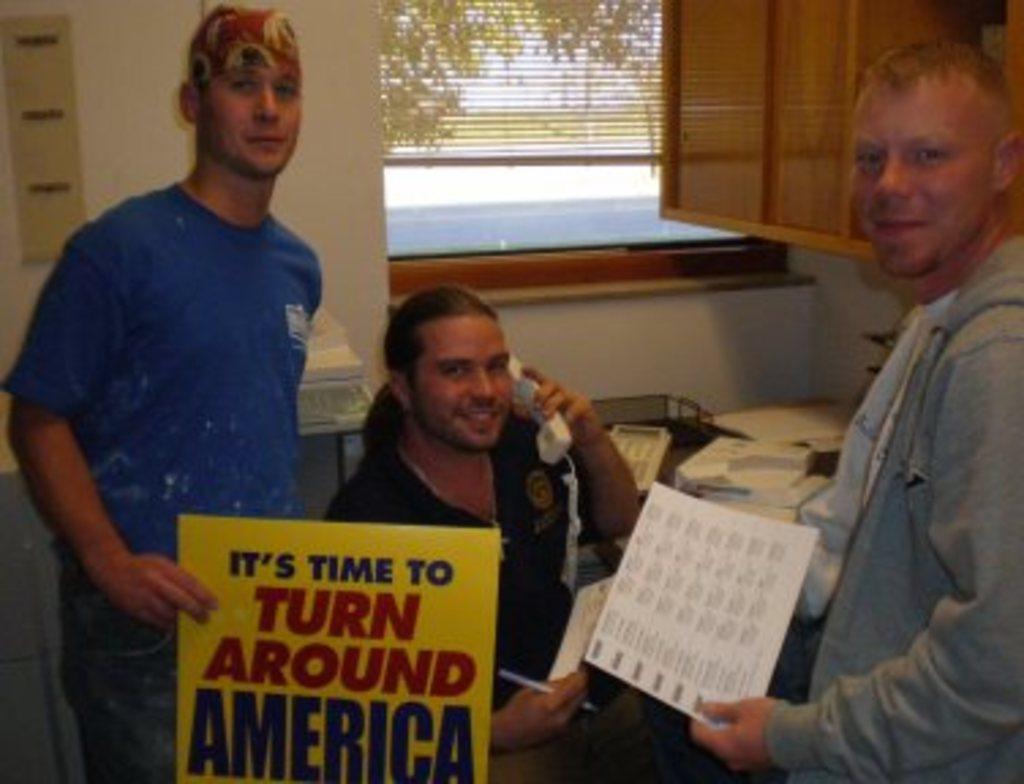Describe this image in one or two sentences. In this image there are people. They are holding boards and we can see a table. There are some objects placed on the table. In the background there is a wall and we can see a window. We can see trees and sky through the window. 